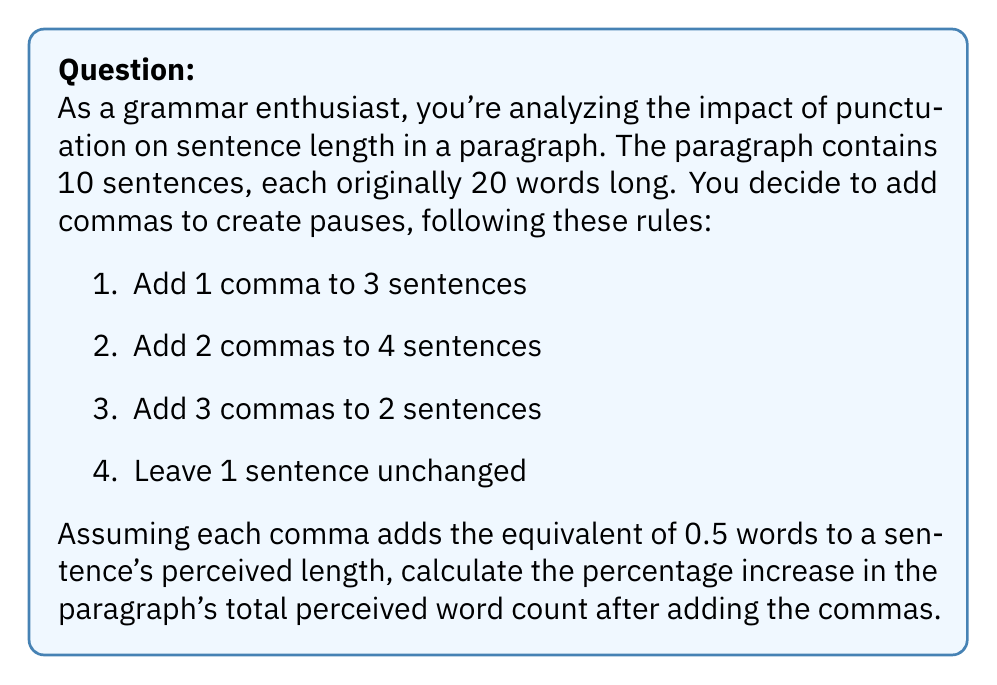Can you answer this question? Let's approach this step-by-step:

1) First, calculate the original word count:
   $$ \text{Original count} = 10 \text{ sentences} \times 20 \text{ words} = 200 \text{ words} $$

2) Now, let's calculate the additional perceived words from commas:
   - 3 sentences with 1 comma: $3 \times (1 \times 0.5) = 1.5$
   - 4 sentences with 2 commas: $4 \times (2 \times 0.5) = 4$
   - 2 sentences with 3 commas: $2 \times (3 \times 0.5) = 3$
   - 1 sentence unchanged: $0$

3) Total additional perceived words:
   $$ 1.5 + 4 + 3 + 0 = 8.5 \text{ words} $$

4) New perceived word count:
   $$ 200 + 8.5 = 208.5 \text{ words} $$

5) Calculate the percentage increase:
   $$ \text{Percentage increase} = \frac{\text{Increase}}{\text{Original}} \times 100\% $$
   $$ = \frac{208.5 - 200}{200} \times 100\% $$
   $$ = \frac{8.5}{200} \times 100\% $$
   $$ = 0.0425 \times 100\% = 4.25\% $$
Answer: The percentage increase in the paragraph's total perceived word count after adding the commas is 4.25%. 